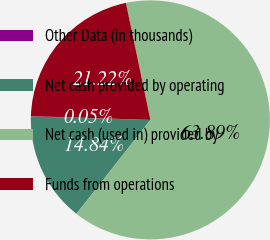Convert chart to OTSL. <chart><loc_0><loc_0><loc_500><loc_500><pie_chart><fcel>Other Data (in thousands)<fcel>Net cash provided by operating<fcel>Net cash (used in) provided by<fcel>Funds from operations<nl><fcel>0.05%<fcel>14.84%<fcel>63.89%<fcel>21.22%<nl></chart> 